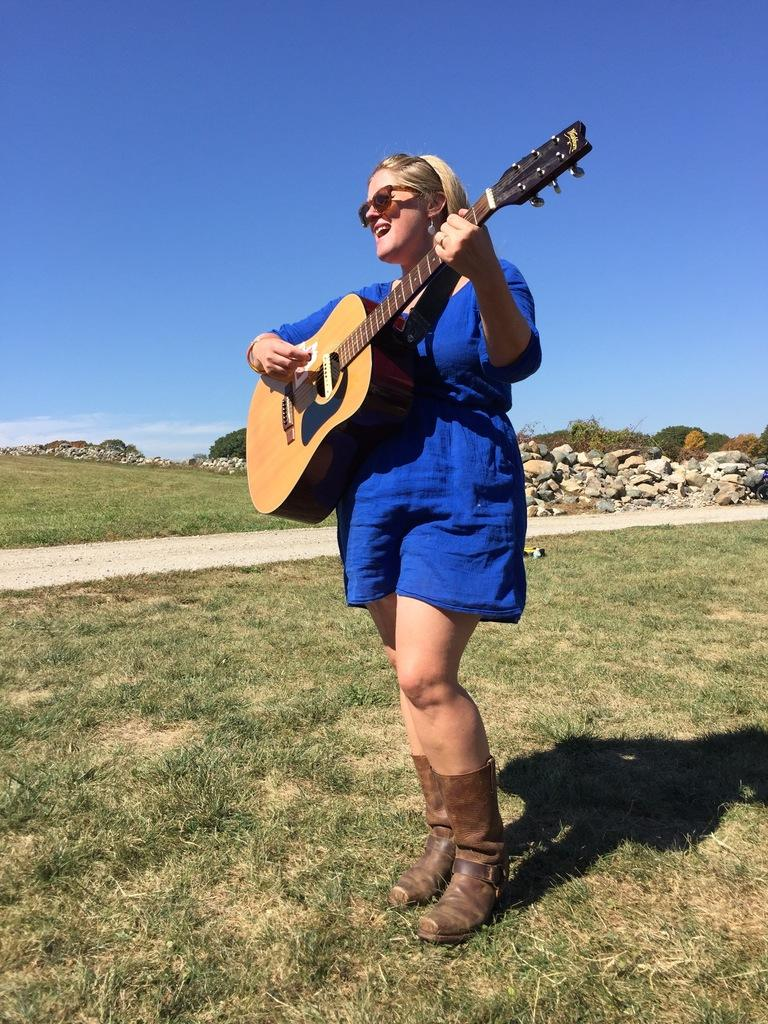Where was the image taken? The image was clicked outside. Who is present in the image? There is a woman in the image. What is the woman wearing? The woman is wearing a blue dress. What is the woman doing in the image? The woman is playing a guitar. What type of vegetation can be seen at the bottom of the image? There is green grass at the bottom of the image. What can be seen in the background of the image? There are rocks, plants, and a blue sky in the background of the image. What type of knife is the woman using to cut the grass in the image? There is no knife present in the image, and the woman is not cutting grass; she is playing a guitar. 